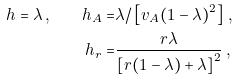<formula> <loc_0><loc_0><loc_500><loc_500>h = \lambda \, , \quad h _ { A } = & \lambda / \left [ v _ { A } ( 1 - \lambda ) ^ { 2 } \right ] \, , \\ h _ { r } = & \frac { r \lambda } { \left [ r ( 1 - \lambda ) + \lambda \right ] ^ { 2 } } \, ,</formula> 